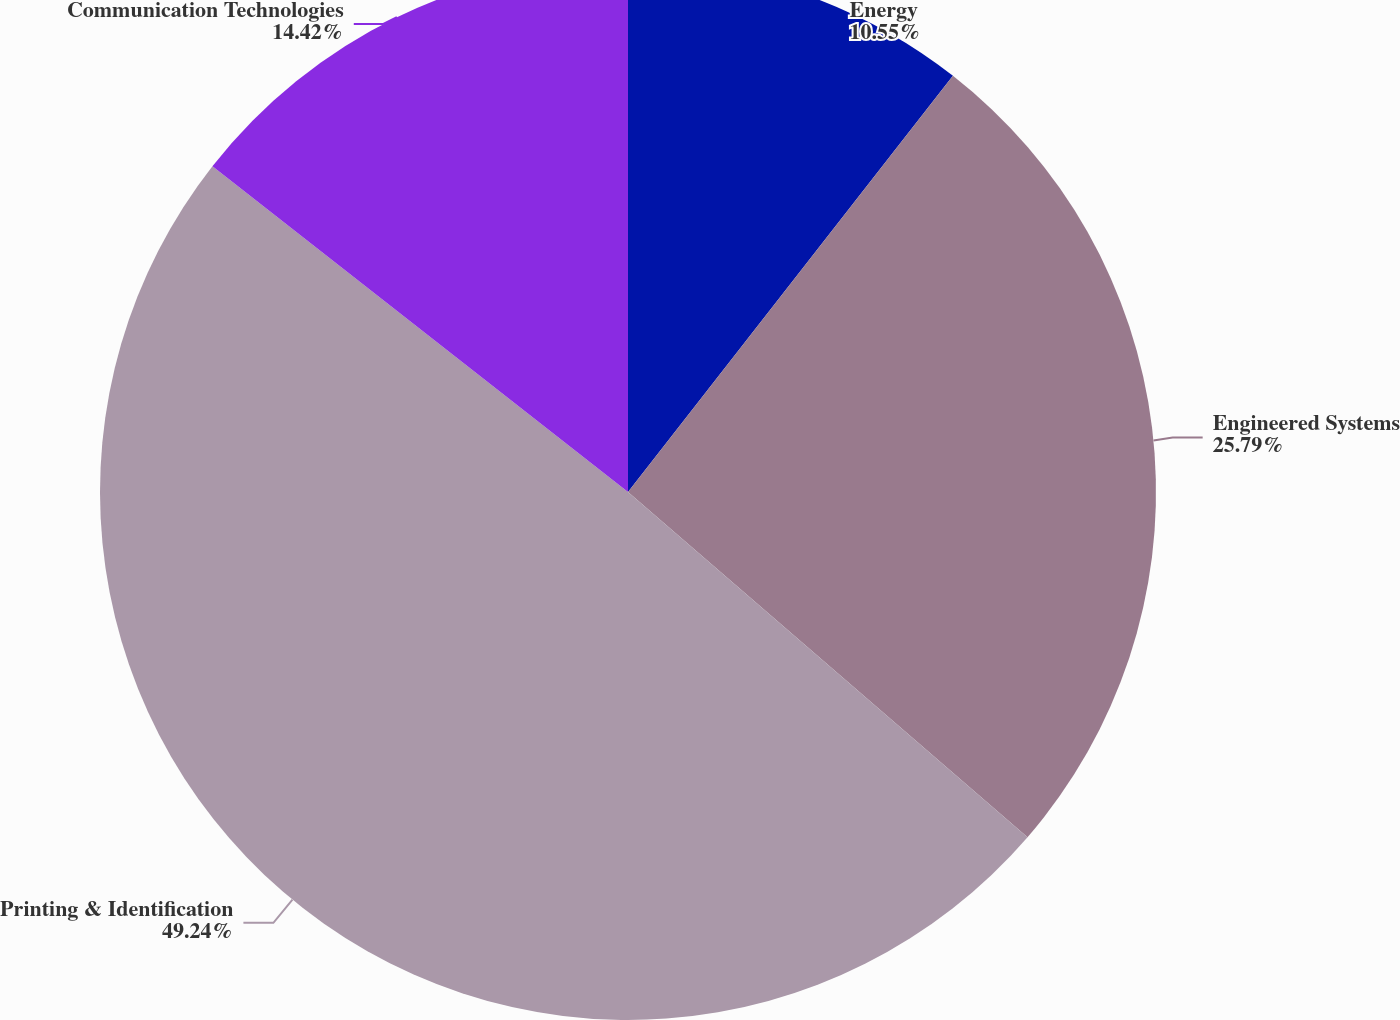Convert chart to OTSL. <chart><loc_0><loc_0><loc_500><loc_500><pie_chart><fcel>Energy<fcel>Engineered Systems<fcel>Printing & Identification<fcel>Communication Technologies<nl><fcel>10.55%<fcel>25.79%<fcel>49.24%<fcel>14.42%<nl></chart> 